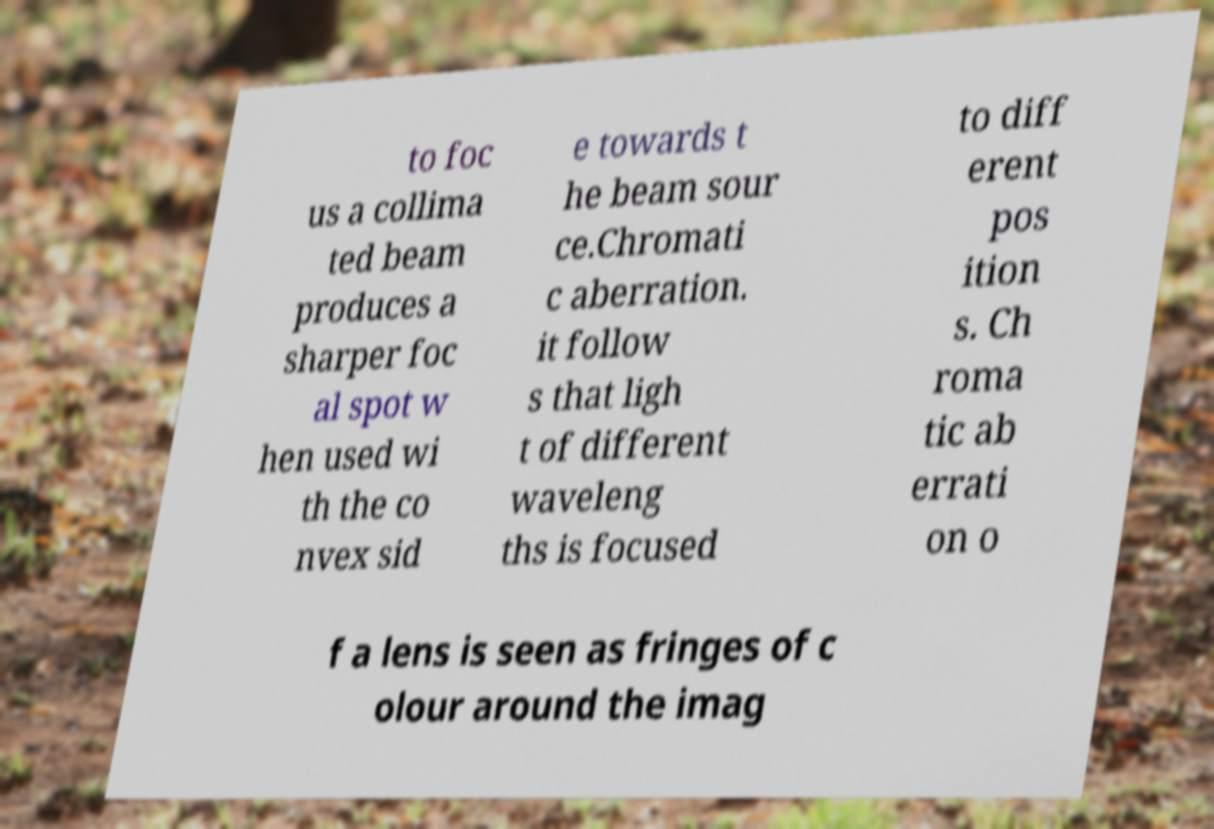There's text embedded in this image that I need extracted. Can you transcribe it verbatim? to foc us a collima ted beam produces a sharper foc al spot w hen used wi th the co nvex sid e towards t he beam sour ce.Chromati c aberration. it follow s that ligh t of different waveleng ths is focused to diff erent pos ition s. Ch roma tic ab errati on o f a lens is seen as fringes of c olour around the imag 